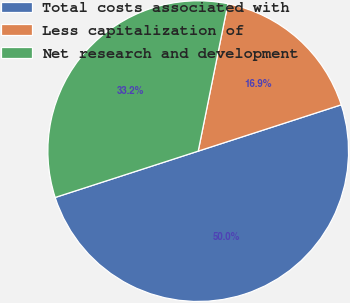<chart> <loc_0><loc_0><loc_500><loc_500><pie_chart><fcel>Total costs associated with<fcel>Less capitalization of<fcel>Net research and development<nl><fcel>50.0%<fcel>16.85%<fcel>33.15%<nl></chart> 